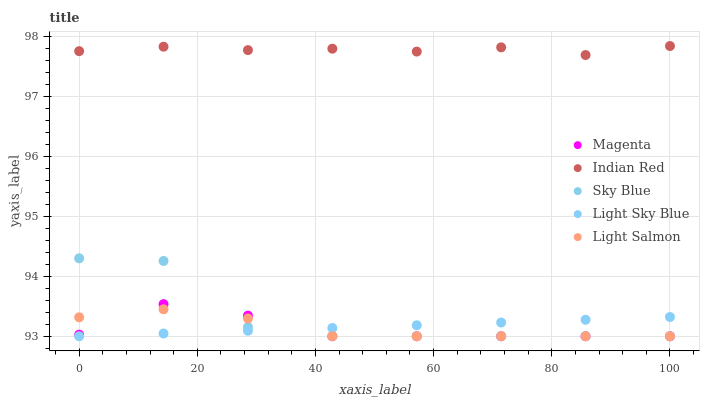Does Magenta have the minimum area under the curve?
Answer yes or no. Yes. Does Indian Red have the maximum area under the curve?
Answer yes or no. Yes. Does Light Sky Blue have the minimum area under the curve?
Answer yes or no. No. Does Light Sky Blue have the maximum area under the curve?
Answer yes or no. No. Is Light Sky Blue the smoothest?
Answer yes or no. Yes. Is Sky Blue the roughest?
Answer yes or no. Yes. Is Magenta the smoothest?
Answer yes or no. No. Is Magenta the roughest?
Answer yes or no. No. Does Sky Blue have the lowest value?
Answer yes or no. Yes. Does Indian Red have the lowest value?
Answer yes or no. No. Does Indian Red have the highest value?
Answer yes or no. Yes. Does Magenta have the highest value?
Answer yes or no. No. Is Light Salmon less than Indian Red?
Answer yes or no. Yes. Is Indian Red greater than Sky Blue?
Answer yes or no. Yes. Does Sky Blue intersect Light Sky Blue?
Answer yes or no. Yes. Is Sky Blue less than Light Sky Blue?
Answer yes or no. No. Is Sky Blue greater than Light Sky Blue?
Answer yes or no. No. Does Light Salmon intersect Indian Red?
Answer yes or no. No. 